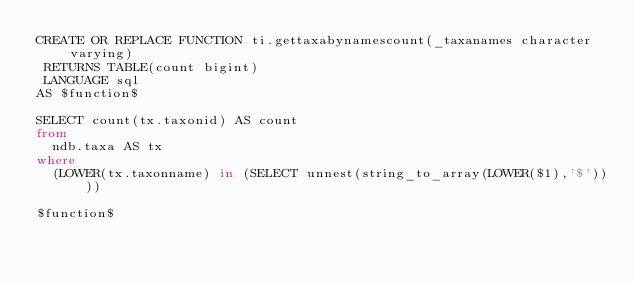<code> <loc_0><loc_0><loc_500><loc_500><_SQL_>CREATE OR REPLACE FUNCTION ti.gettaxabynamescount(_taxanames character varying)
 RETURNS TABLE(count bigint)
 LANGUAGE sql
AS $function$

SELECT count(tx.taxonid) AS count
from
  ndb.taxa AS tx
where
  (LOWER(tx.taxonname) in (SELECT unnest(string_to_array(LOWER($1),'$'))))

$function$
</code> 